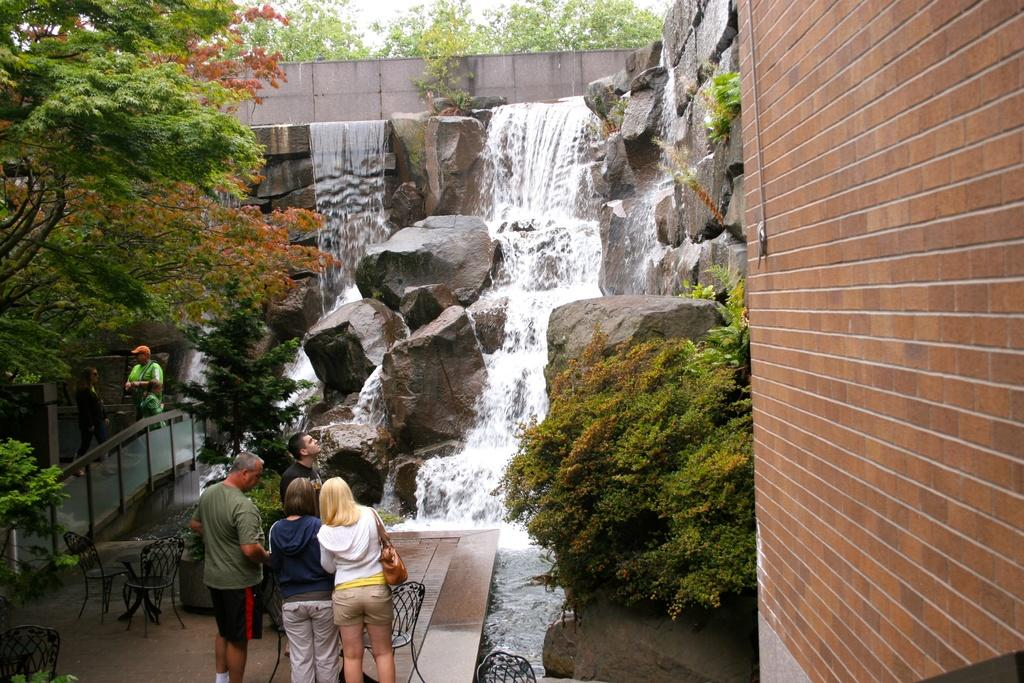What are the people in the image doing? The group of people is standing on the ground in the image. What type of natural elements can be seen in the image? Trees, plants, and water flow are visible in the image. What objects are present in the image that might be used for sitting? Chairs are present in the image. What type of terrain is visible in the image? Rocks are present in the image. What architectural features can be seen in the image? There is a railing and a wall visible in the image. What part of the natural environment is visible in the image? The sky is visible in the image. What type of news can be heard being read by the people in the image? There is no indication in the image that the people are reading or listening to any news. What type of boat is visible in the image? There is no boat present in the image. 